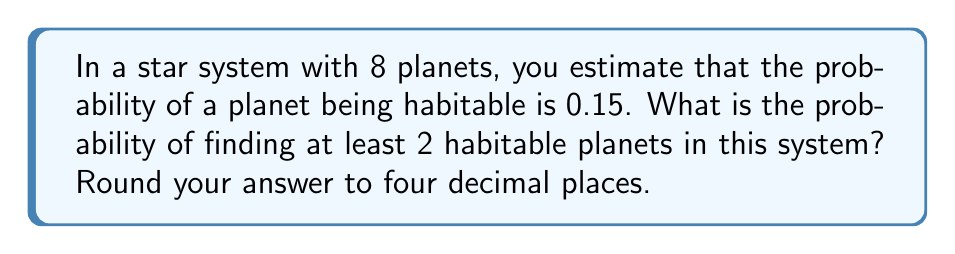Provide a solution to this math problem. Let's approach this step-by-step using the binomial probability distribution:

1) We can model this as a binomial distribution where:
   $n = 8$ (number of planets)
   $p = 0.15$ (probability of a planet being habitable)
   $X$ = number of habitable planets

2) We want $P(X \geq 2)$, which is equivalent to $1 - P(X < 2)$ or $1 - [P(X = 0) + P(X = 1)]$

3) The probability mass function for a binomial distribution is:

   $P(X = k) = \binom{n}{k} p^k (1-p)^{n-k}$

4) Let's calculate $P(X = 0)$ and $P(X = 1)$:

   $P(X = 0) = \binom{8}{0} (0.15)^0 (0.85)^8 = 1 \cdot 1 \cdot 0.85^8 = 0.2725$

   $P(X = 1) = \binom{8}{1} (0.15)^1 (0.85)^7 = 8 \cdot 0.15 \cdot 0.85^7 = 0.3851$

5) Now we can calculate $P(X \geq 2)$:

   $P(X \geq 2) = 1 - [P(X = 0) + P(X = 1)]$
                $= 1 - (0.2725 + 0.3851)$
                $= 1 - 0.6576$
                $= 0.3424$

6) Rounding to four decimal places: 0.3424
Answer: 0.3424 